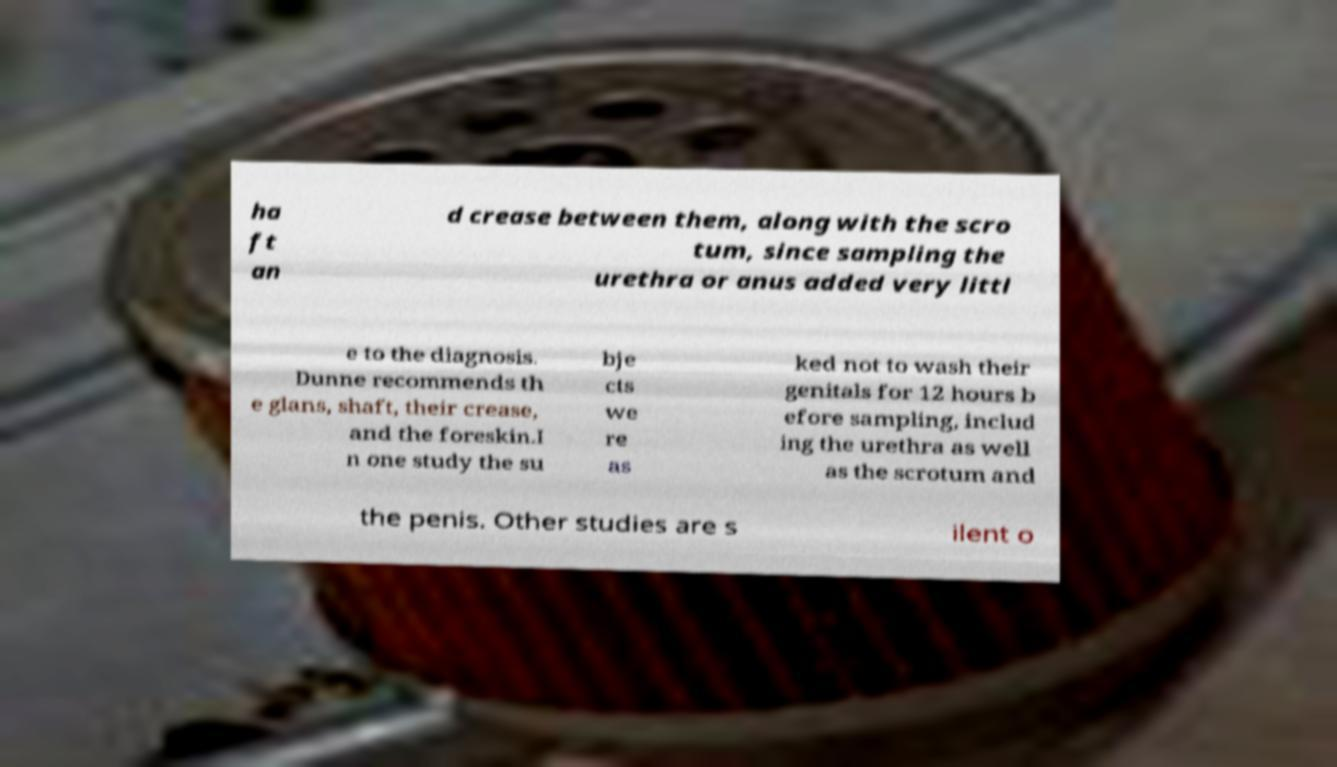Could you assist in decoding the text presented in this image and type it out clearly? ha ft an d crease between them, along with the scro tum, since sampling the urethra or anus added very littl e to the diagnosis. Dunne recommends th e glans, shaft, their crease, and the foreskin.I n one study the su bje cts we re as ked not to wash their genitals for 12 hours b efore sampling, includ ing the urethra as well as the scrotum and the penis. Other studies are s ilent o 